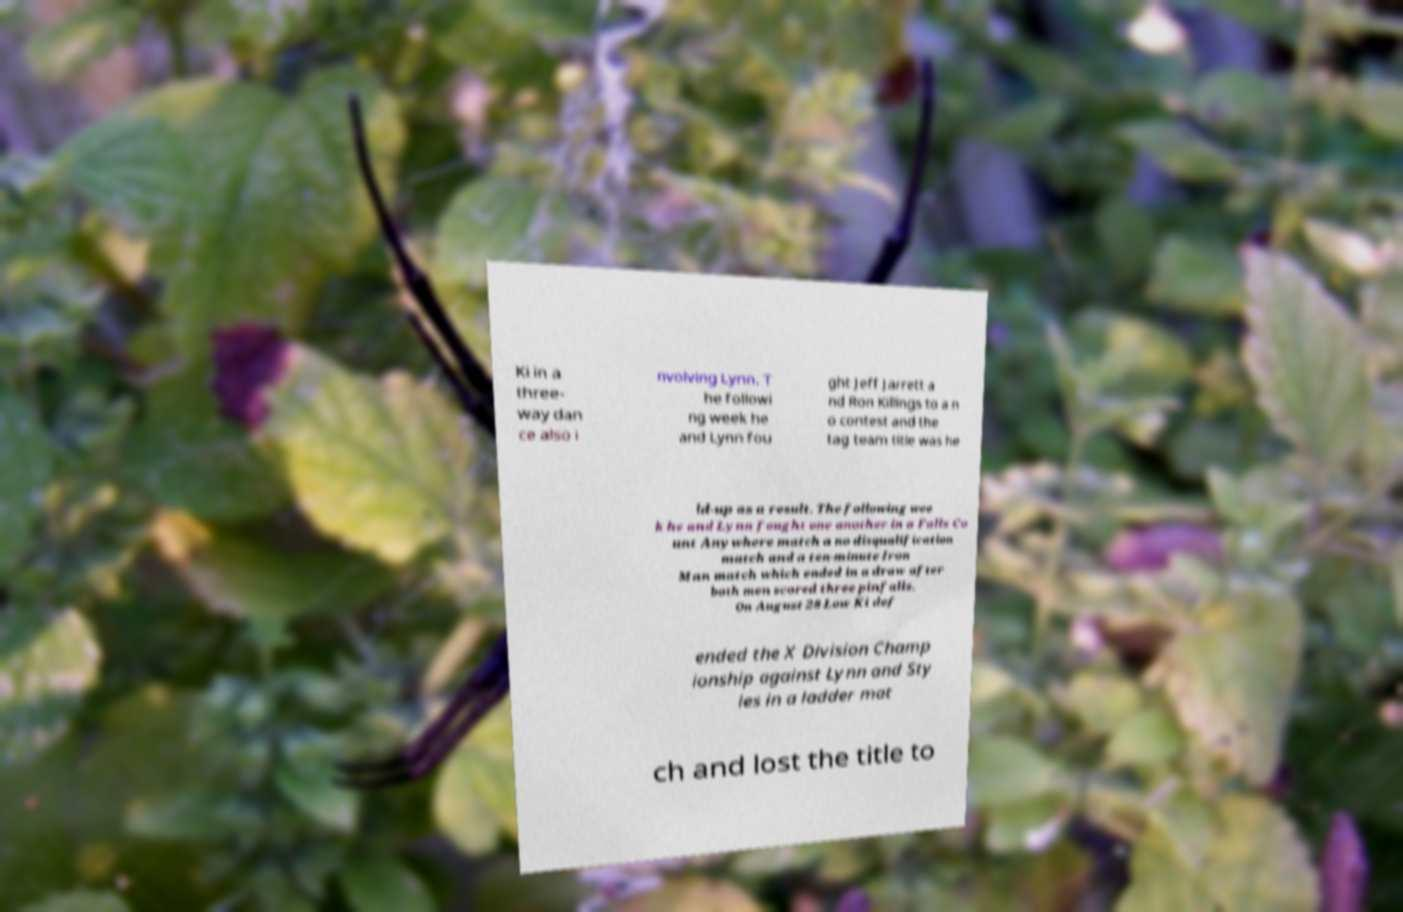There's text embedded in this image that I need extracted. Can you transcribe it verbatim? Ki in a three- way dan ce also i nvolving Lynn. T he followi ng week he and Lynn fou ght Jeff Jarrett a nd Ron Killings to a n o contest and the tag team title was he ld-up as a result. The following wee k he and Lynn fought one another in a Falls Co unt Anywhere match a no disqualification match and a ten-minute Iron Man match which ended in a draw after both men scored three pinfalls. On August 28 Low Ki def ended the X Division Champ ionship against Lynn and Sty les in a ladder mat ch and lost the title to 